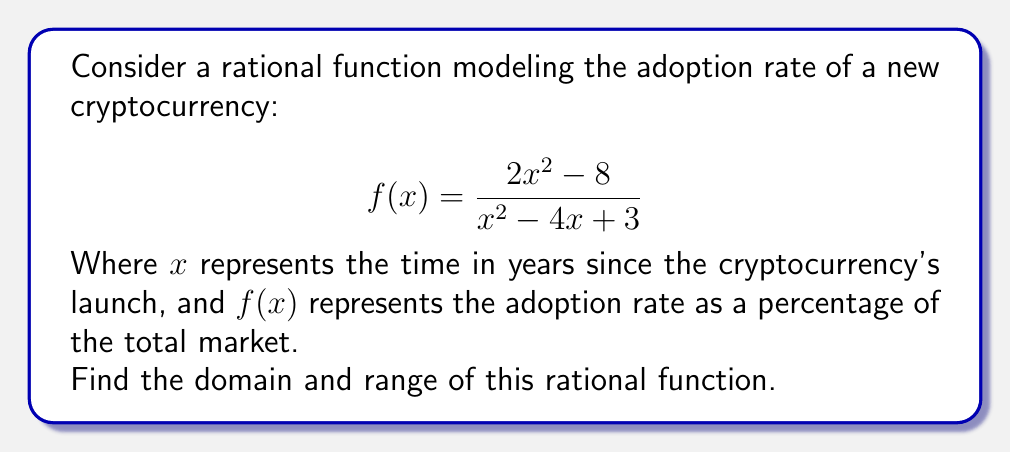Help me with this question. Step 1: Determine the domain
To find the domain, we need to identify values of x that make the denominator zero:

$$x^2 - 4x + 3 = 0$$

Using the quadratic formula, we get:
$$x = \frac{4 \pm \sqrt{16 - 12}}{2} = \frac{4 \pm 2}{2}$$

So, $x = 1$ or $x = 3$

The domain is all real numbers except 1 and 3.

Step 2: Find the horizontal asymptote
To find the range, we first need to determine the horizontal asymptote:

$$\lim_{x \to \infty} \frac{2x^2 - 8}{x^2 - 4x + 3} = \lim_{x \to \infty} \frac{2 - 8/x^2}{1 - 4/x + 3/x^2} = 2$$

The horizontal asymptote is y = 2.

Step 3: Find vertical asymptotes
Vertical asymptotes occur at x = 1 and x = 3 (where the denominator is zero).

Step 4: Analyze behavior near asymptotes
As x approaches 1 or 3 from either side, f(x) approaches positive or negative infinity.

Step 5: Determine the range
Given the vertical asymptotes and the horizontal asymptote, the function will take on all values except 2.

Therefore, the range is all real numbers except 2.
Answer: Domain: $x \in \mathbb{R}, x \neq 1, x \neq 3$
Range: $y \in \mathbb{R}, y \neq 2$ 